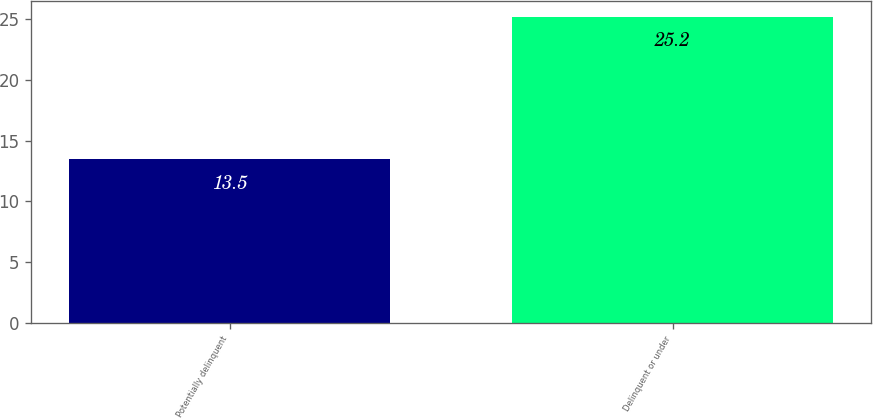<chart> <loc_0><loc_0><loc_500><loc_500><bar_chart><fcel>Potentially delinquent<fcel>Delinquent or under<nl><fcel>13.5<fcel>25.2<nl></chart> 